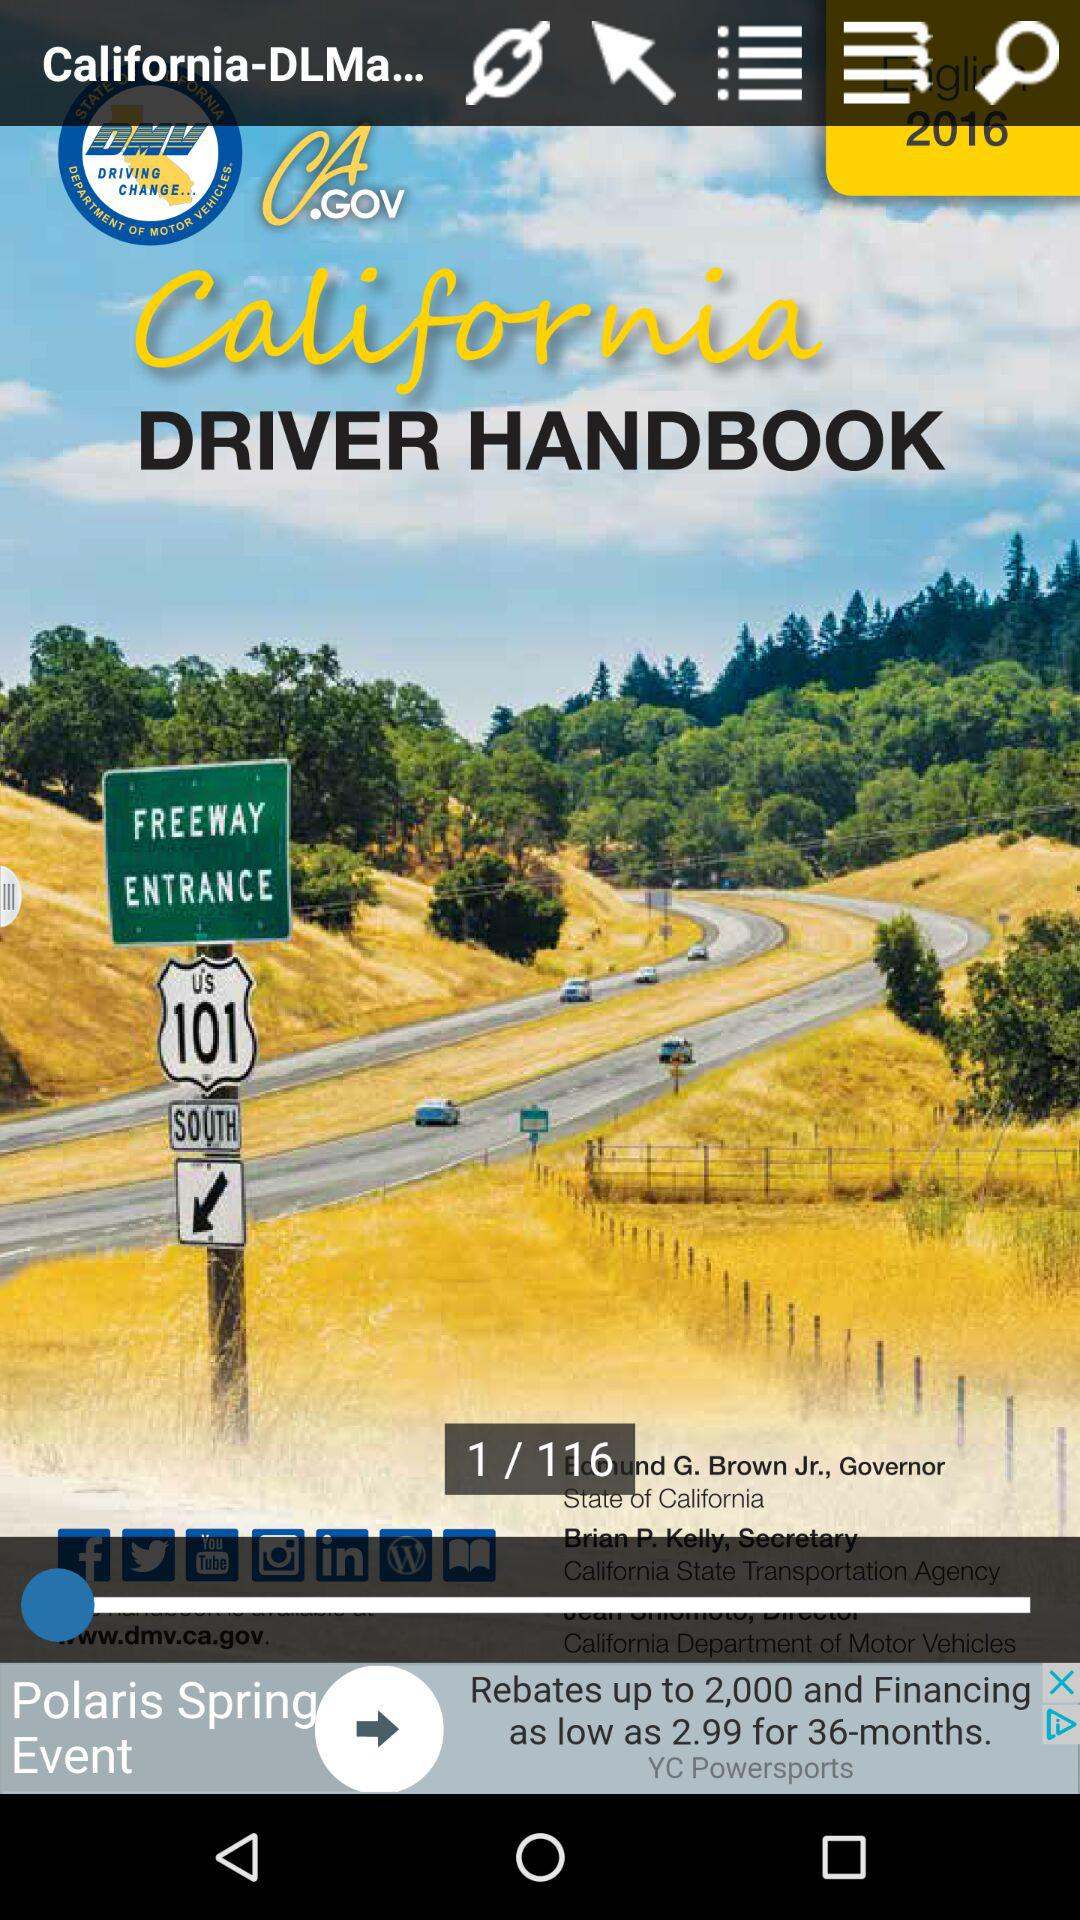How many pages are there in total? There are 116 pages in total. 